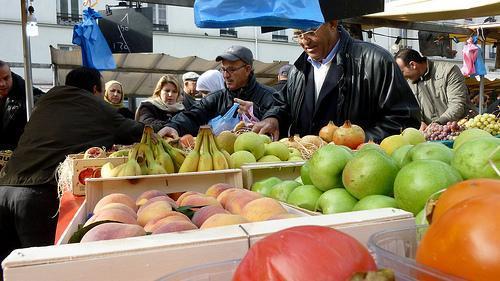How many people are wearing glasses?
Give a very brief answer. 2. 